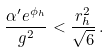<formula> <loc_0><loc_0><loc_500><loc_500>\frac { \alpha ^ { \prime } e ^ { \phi _ { h } } } { g ^ { 2 } } < \frac { r _ { h } ^ { 2 } } { \sqrt { 6 } } \, .</formula> 